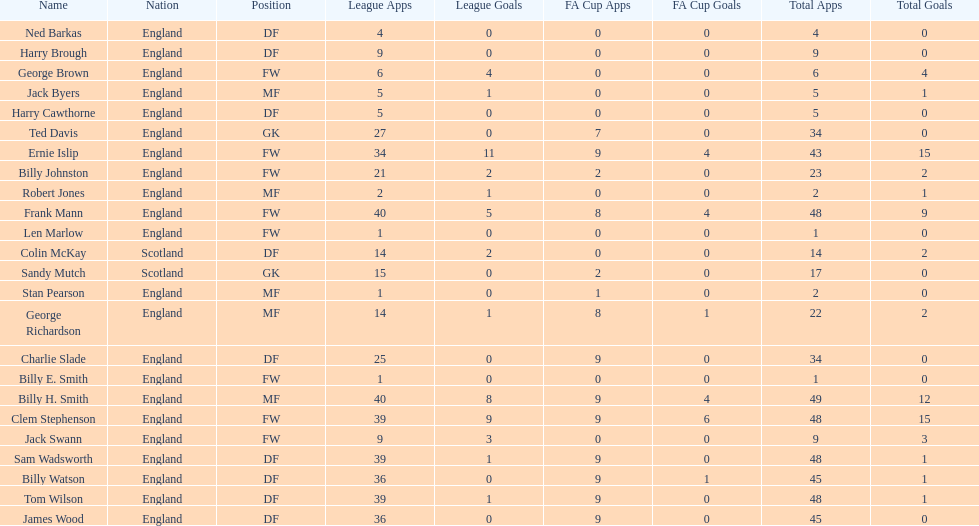What are the total league apps owned by ted davis? 27. 